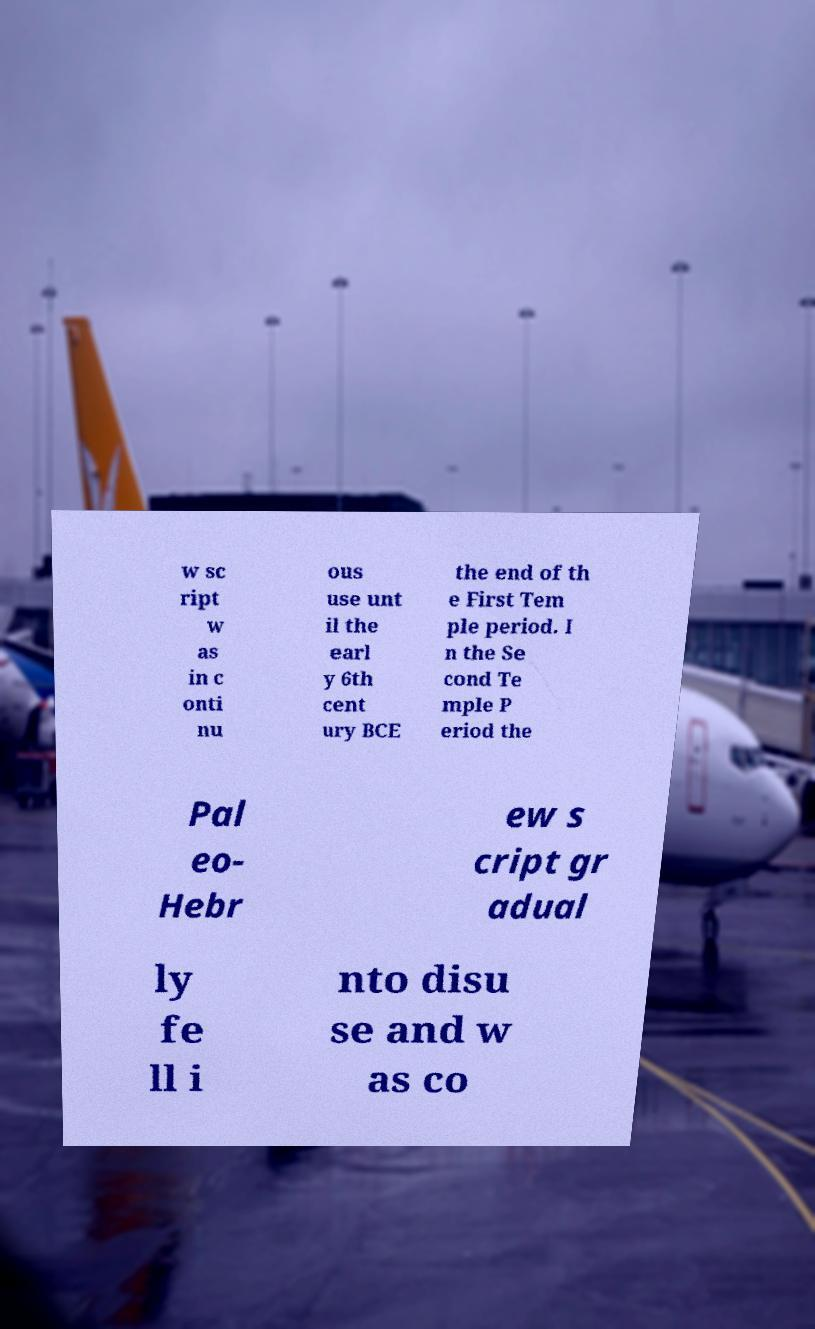Please read and relay the text visible in this image. What does it say? w sc ript w as in c onti nu ous use unt il the earl y 6th cent ury BCE the end of th e First Tem ple period. I n the Se cond Te mple P eriod the Pal eo- Hebr ew s cript gr adual ly fe ll i nto disu se and w as co 